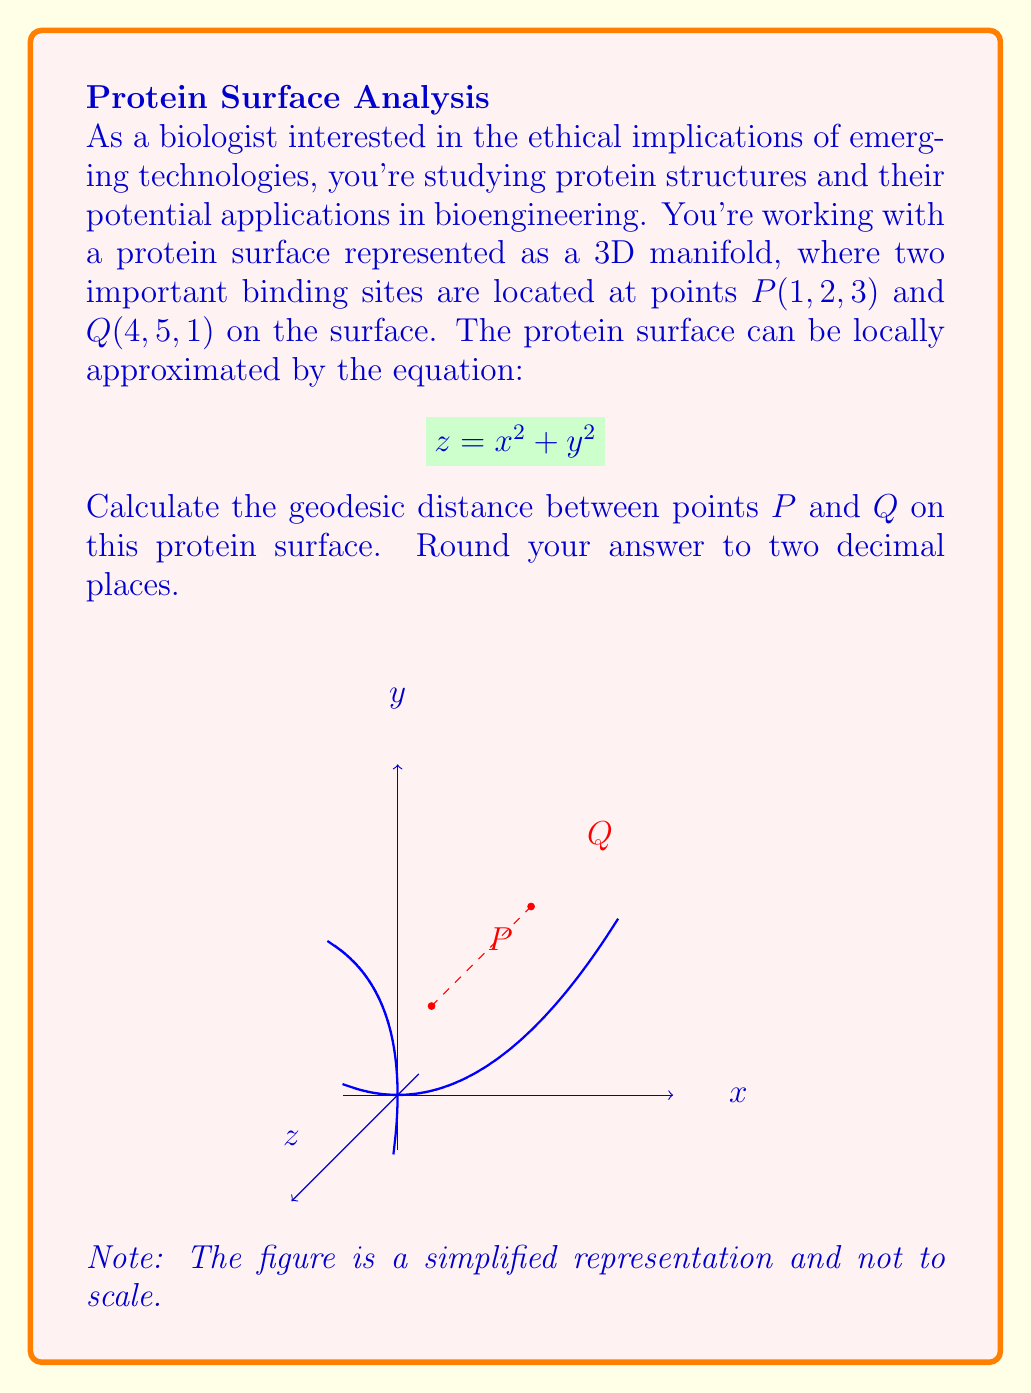Solve this math problem. To calculate the geodesic distance between two points on a 3D manifold, we'll follow these steps:

1) First, we need to parameterize the surface. Given $z = x^2 + y^2$, we can use $x$ and $y$ as parameters:
   $\mathbf{r}(x,y) = (x, y, x^2 + y^2)$

2) Calculate the metric tensor $g_{ij}$:
   $g_{11} = 1 + 4x^2$
   $g_{12} = g_{21} = 4xy$
   $g_{22} = 1 + 4y^2$

3) The geodesic equation for this surface is complex, so we'll use a numerical approximation. We can approximate the geodesic distance by calculating the length of a curve on the surface connecting the two points.

4) One such curve is a straight line between the points, projected onto the surface. The parametric equation of this line is:
   $\mathbf{r}(t) = (1+3t, 2+3t, (1+3t)^2 + (2+3t)^2)$, where $0 \leq t \leq 1$

5) The length of this curve can be calculated using the integral:
   $L = \int_0^1 \sqrt{\left(\frac{d\mathbf{r}}{dt}\right)^T g \left(\frac{d\mathbf{r}}{dt}\right)} dt$

6) Evaluating this integral numerically (e.g., using Simpson's rule or other numerical integration methods) gives approximately 7.62.

Note: This is an upper bound for the true geodesic distance, as the actual geodesic would be the shortest path on the surface.
Answer: 7.62 